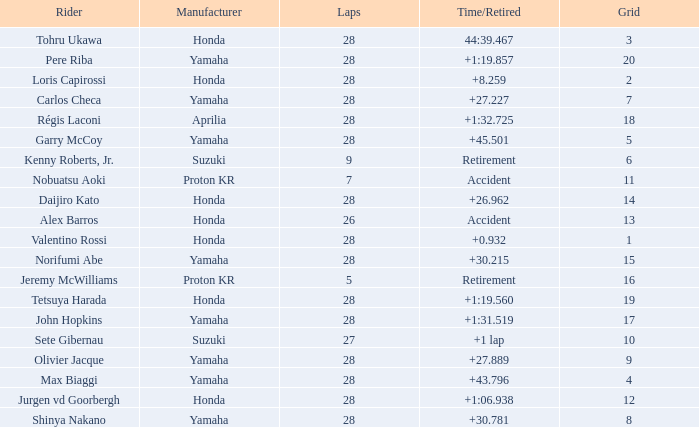How many laps did pere riba ride? 28.0. 